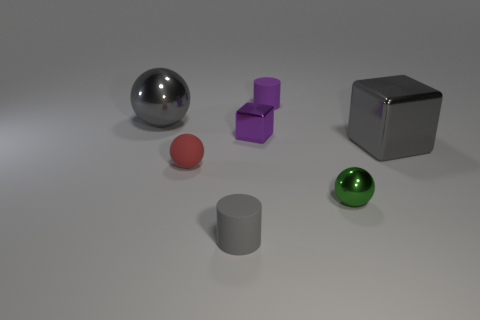There is a small purple thing in front of the large gray sphere; what number of purple metallic blocks are to the right of it?
Provide a short and direct response. 0. Are there any large blocks of the same color as the small rubber sphere?
Your response must be concise. No. Do the gray ball and the purple matte object have the same size?
Keep it short and to the point. No. Is the color of the big metal block the same as the large sphere?
Provide a short and direct response. Yes. What is the material of the large object left of the cylinder that is in front of the large metallic sphere?
Offer a very short reply. Metal. What is the material of the other tiny object that is the same shape as the gray matte thing?
Ensure brevity in your answer.  Rubber. Is the size of the matte cylinder behind the green ball the same as the purple metallic block?
Provide a succinct answer. Yes. How many metal things are either small blocks or cylinders?
Keep it short and to the point. 1. There is a object that is to the right of the tiny purple cylinder and in front of the big metal block; what material is it?
Make the answer very short. Metal. Are the small red thing and the small gray thing made of the same material?
Offer a very short reply. Yes. 